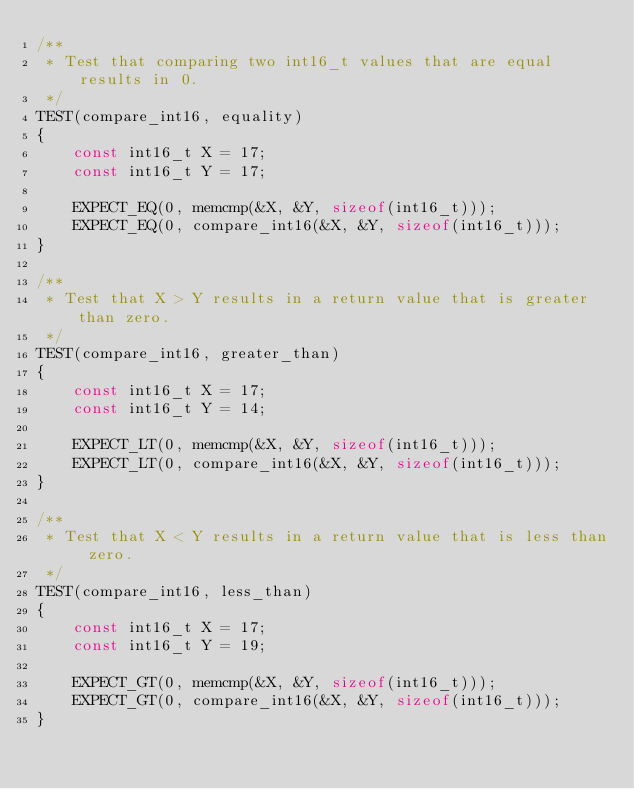<code> <loc_0><loc_0><loc_500><loc_500><_C++_>/**
 * Test that comparing two int16_t values that are equal results in 0.
 */
TEST(compare_int16, equality)
{
    const int16_t X = 17;
    const int16_t Y = 17;

    EXPECT_EQ(0, memcmp(&X, &Y, sizeof(int16_t)));
    EXPECT_EQ(0, compare_int16(&X, &Y, sizeof(int16_t)));
}

/**
 * Test that X > Y results in a return value that is greater than zero.
 */
TEST(compare_int16, greater_than)
{
    const int16_t X = 17;
    const int16_t Y = 14;

    EXPECT_LT(0, memcmp(&X, &Y, sizeof(int16_t)));
    EXPECT_LT(0, compare_int16(&X, &Y, sizeof(int16_t)));
}

/**
 * Test that X < Y results in a return value that is less than zero.
 */
TEST(compare_int16, less_than)
{
    const int16_t X = 17;
    const int16_t Y = 19;

    EXPECT_GT(0, memcmp(&X, &Y, sizeof(int16_t)));
    EXPECT_GT(0, compare_int16(&X, &Y, sizeof(int16_t)));
}
</code> 